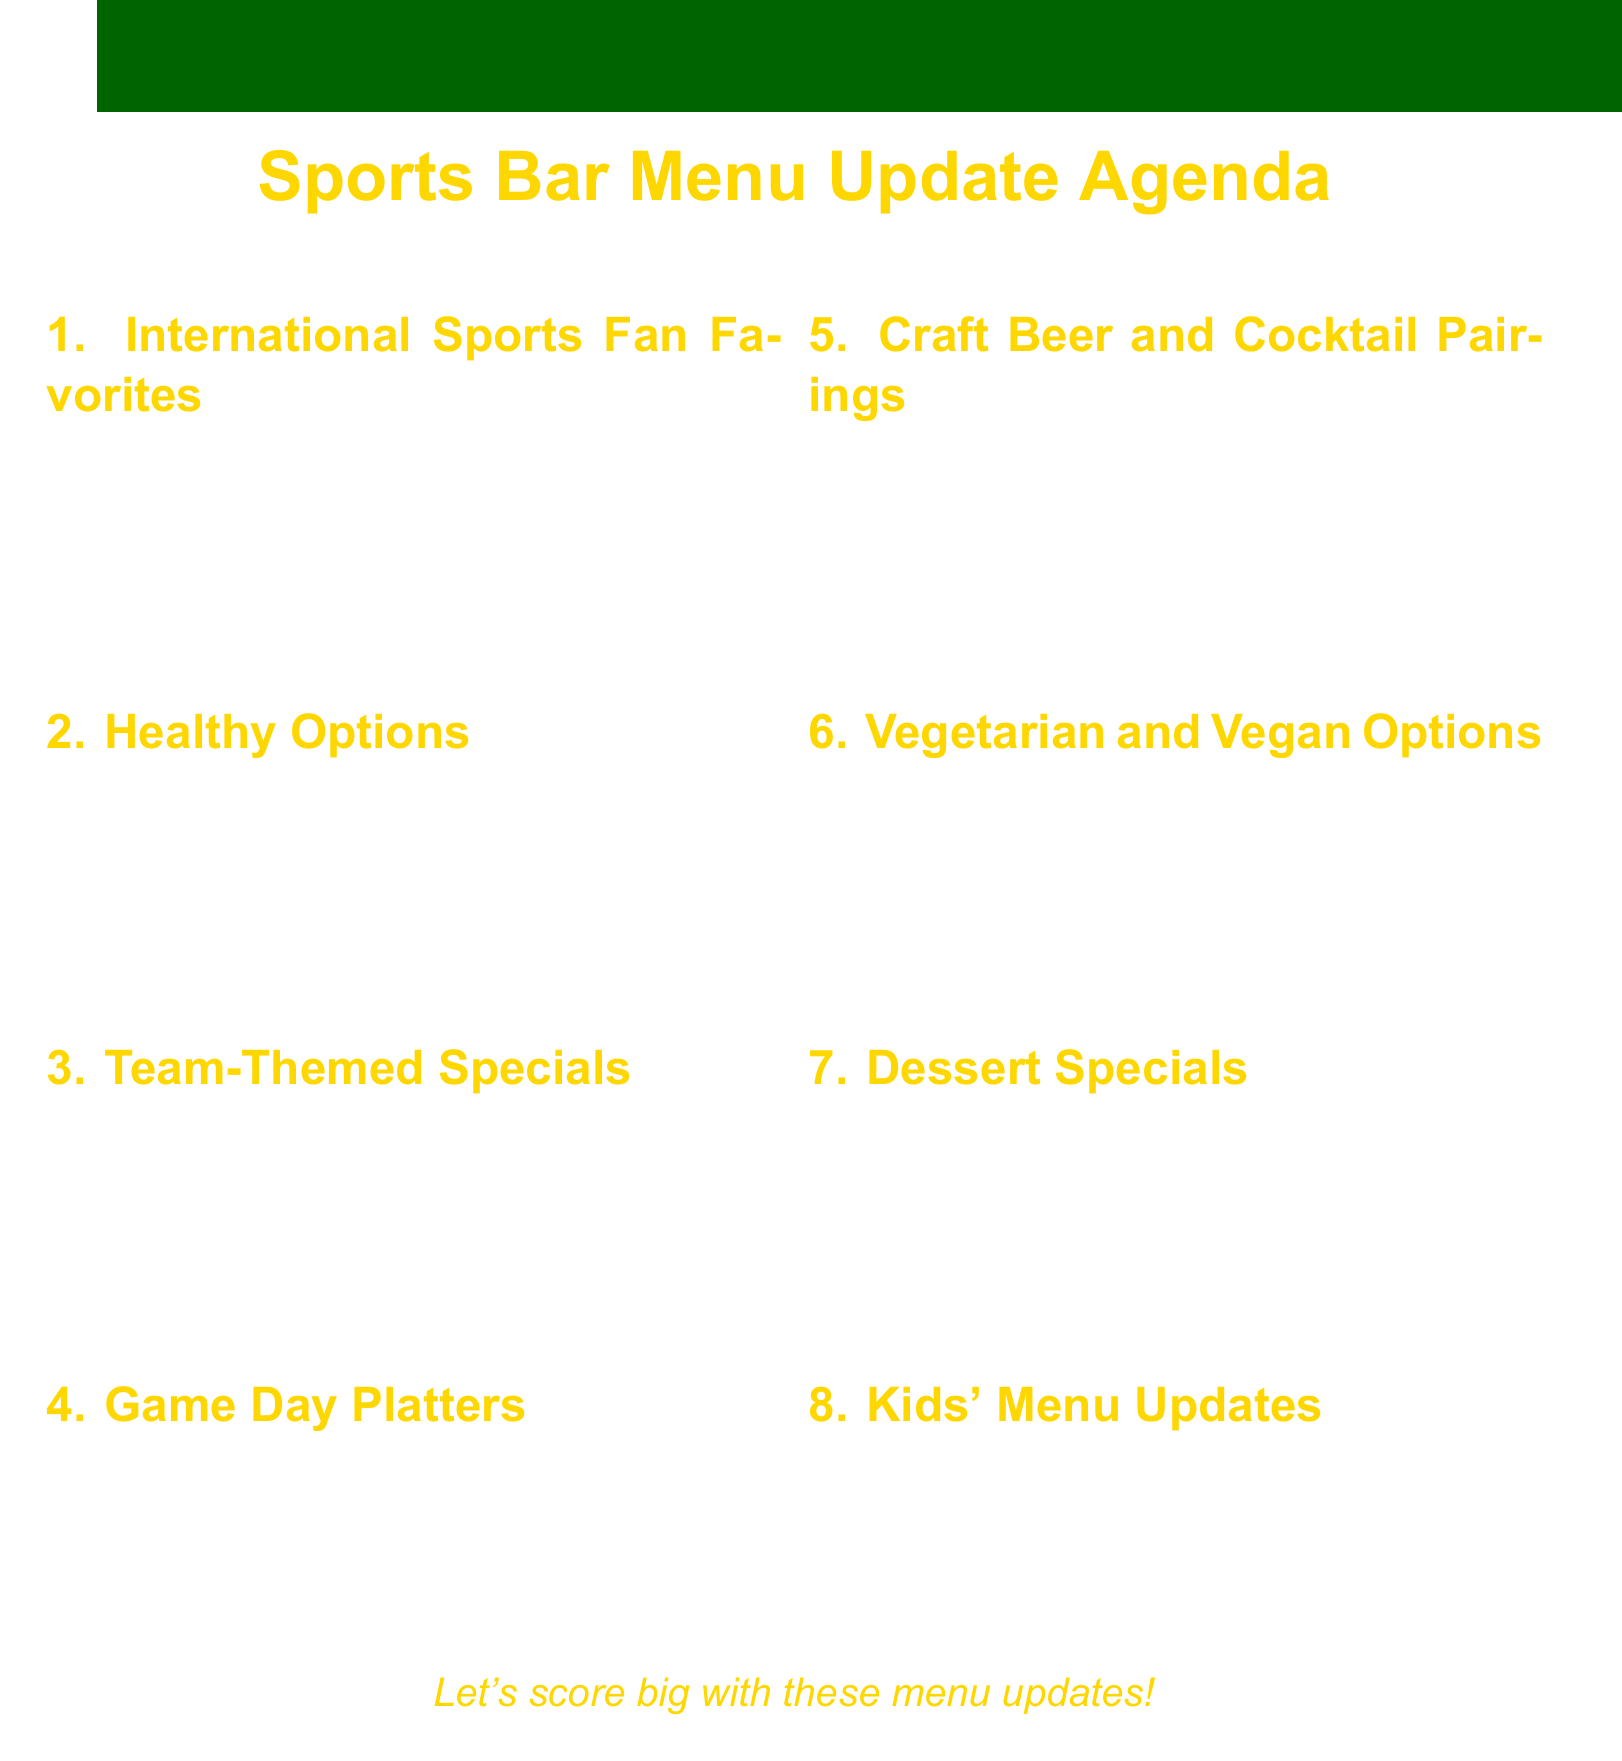What is the first agenda item? The first agenda item listed in the document is "International Sports Fan Favorites."
Answer: International Sports Fan Favorites How many examples are provided for healthy options? There are three examples of healthy options presented in the agenda.
Answer: 3 What type of dish is associated with the New England Patriots? The dish inspired by the New England Patriots is "Clam Chowder."
Answer: Clam Chowder Which menu section includes shareable platters? The section dedicated to shareable platters is called "Game Day Platters."
Answer: Game Day Platters What dessert has a sports theme related to basketball? The dessert relating to basketball in the document is "Basketball-shaped cake pops."
Answer: Basketball-shaped cake pops What dietary preferences are accommodated in the vegetarian and vegan options? The vegetarian and vegan options are designed to accommodate meat-free choices.
Answer: Meat-free choices How many items are listed under the Kids' Menu Updates? There are three items listed under the Kids' Menu Updates section.
Answer: 3 What is the aim of creating "Team-Themed Specials"? The aim is to create dishes inspired by local and popular sports teams.
Answer: Inspired by local and popular sports teams What type of drinks are suggested to complement the new menu items? The suggested drinks to complement the new menu items are "Craft Beer and Cocktail Pairings."
Answer: Craft Beer and Cocktail Pairings 